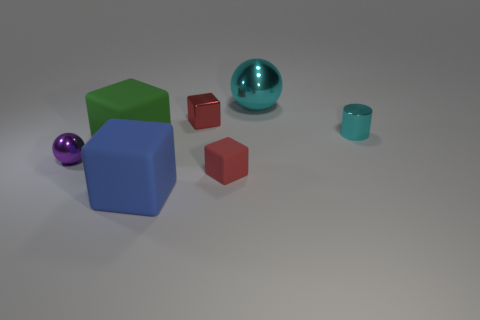There is a big rubber cube that is in front of the shiny sphere that is in front of the big cyan metallic sphere; are there any small metallic things in front of it?
Keep it short and to the point. No. Is the tiny purple thing the same shape as the green matte object?
Offer a terse response. No. Are there fewer blue things that are to the left of the green matte thing than tiny gray rubber things?
Your answer should be very brief. No. What color is the metal ball right of the tiny red thing that is in front of the large rubber object that is behind the tiny metal ball?
Offer a very short reply. Cyan. What number of metallic objects are green objects or red things?
Your answer should be very brief. 1. Does the blue cube have the same size as the red matte thing?
Keep it short and to the point. No. Is the number of large blue matte things that are to the right of the red metallic thing less than the number of large cyan metal spheres that are on the left side of the red rubber thing?
Make the answer very short. No. Is there anything else that is the same size as the purple sphere?
Offer a very short reply. Yes. How big is the red shiny thing?
Provide a succinct answer. Small. How many big objects are either red matte objects or cyan metal objects?
Offer a terse response. 1. 